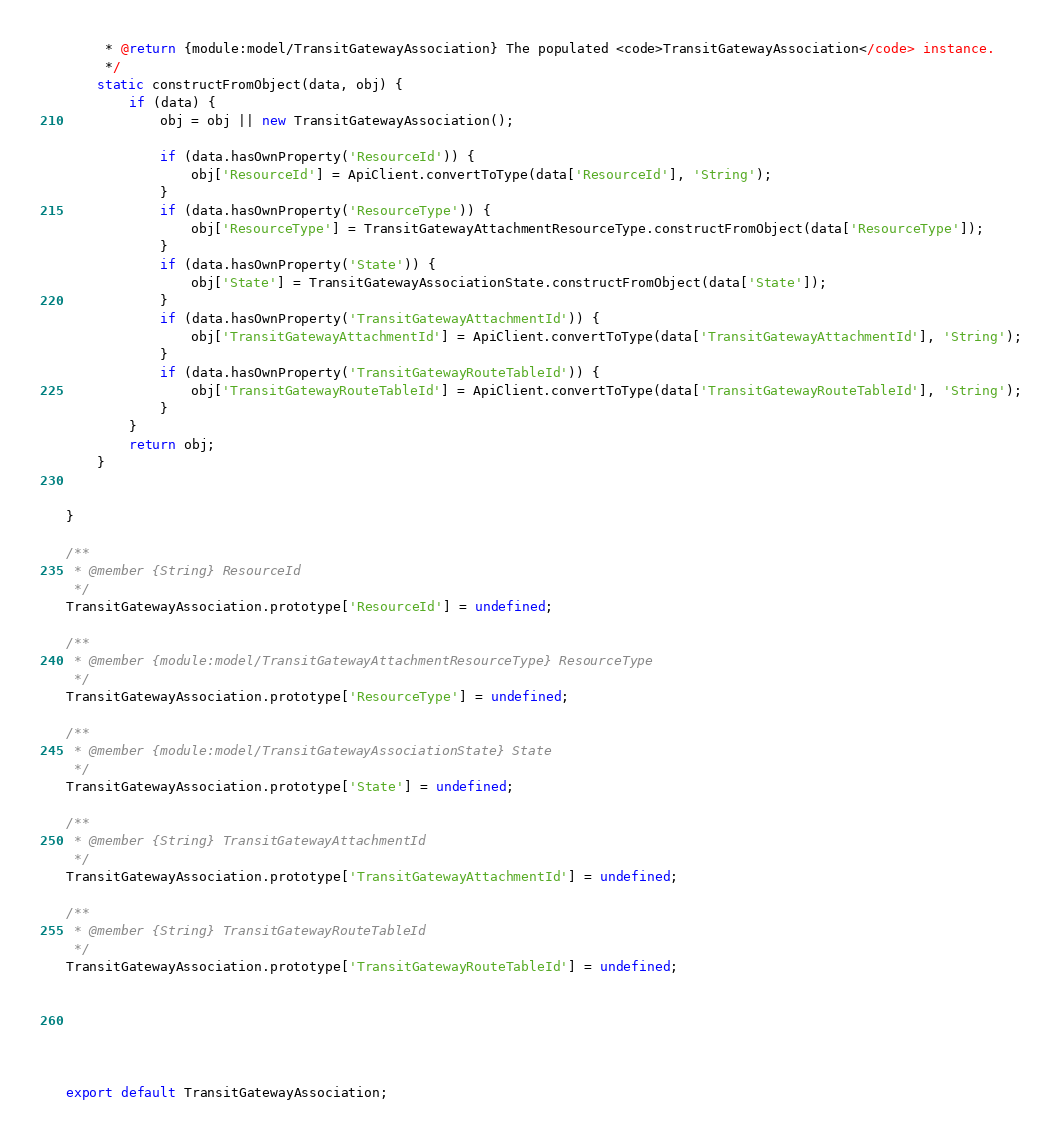Convert code to text. <code><loc_0><loc_0><loc_500><loc_500><_JavaScript_>     * @return {module:model/TransitGatewayAssociation} The populated <code>TransitGatewayAssociation</code> instance.
     */
    static constructFromObject(data, obj) {
        if (data) {
            obj = obj || new TransitGatewayAssociation();

            if (data.hasOwnProperty('ResourceId')) {
                obj['ResourceId'] = ApiClient.convertToType(data['ResourceId'], 'String');
            }
            if (data.hasOwnProperty('ResourceType')) {
                obj['ResourceType'] = TransitGatewayAttachmentResourceType.constructFromObject(data['ResourceType']);
            }
            if (data.hasOwnProperty('State')) {
                obj['State'] = TransitGatewayAssociationState.constructFromObject(data['State']);
            }
            if (data.hasOwnProperty('TransitGatewayAttachmentId')) {
                obj['TransitGatewayAttachmentId'] = ApiClient.convertToType(data['TransitGatewayAttachmentId'], 'String');
            }
            if (data.hasOwnProperty('TransitGatewayRouteTableId')) {
                obj['TransitGatewayRouteTableId'] = ApiClient.convertToType(data['TransitGatewayRouteTableId'], 'String');
            }
        }
        return obj;
    }


}

/**
 * @member {String} ResourceId
 */
TransitGatewayAssociation.prototype['ResourceId'] = undefined;

/**
 * @member {module:model/TransitGatewayAttachmentResourceType} ResourceType
 */
TransitGatewayAssociation.prototype['ResourceType'] = undefined;

/**
 * @member {module:model/TransitGatewayAssociationState} State
 */
TransitGatewayAssociation.prototype['State'] = undefined;

/**
 * @member {String} TransitGatewayAttachmentId
 */
TransitGatewayAssociation.prototype['TransitGatewayAttachmentId'] = undefined;

/**
 * @member {String} TransitGatewayRouteTableId
 */
TransitGatewayAssociation.prototype['TransitGatewayRouteTableId'] = undefined;






export default TransitGatewayAssociation;

</code> 